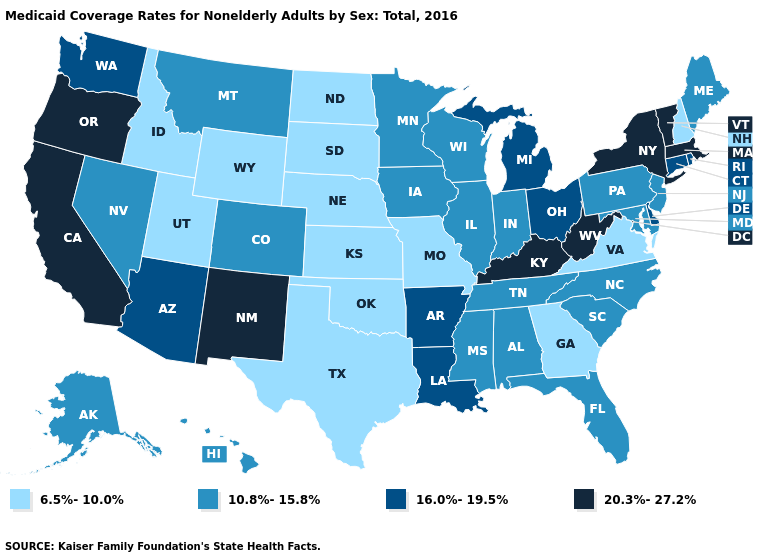Name the states that have a value in the range 20.3%-27.2%?
Be succinct. California, Kentucky, Massachusetts, New Mexico, New York, Oregon, Vermont, West Virginia. Among the states that border Wisconsin , does Iowa have the highest value?
Concise answer only. No. Among the states that border Vermont , does New Hampshire have the lowest value?
Short answer required. Yes. What is the value of Maryland?
Concise answer only. 10.8%-15.8%. Name the states that have a value in the range 6.5%-10.0%?
Keep it brief. Georgia, Idaho, Kansas, Missouri, Nebraska, New Hampshire, North Dakota, Oklahoma, South Dakota, Texas, Utah, Virginia, Wyoming. What is the lowest value in states that border Connecticut?
Answer briefly. 16.0%-19.5%. What is the value of Alaska?
Concise answer only. 10.8%-15.8%. Does the map have missing data?
Give a very brief answer. No. What is the value of Alabama?
Write a very short answer. 10.8%-15.8%. Name the states that have a value in the range 16.0%-19.5%?
Quick response, please. Arizona, Arkansas, Connecticut, Delaware, Louisiana, Michigan, Ohio, Rhode Island, Washington. What is the value of Maine?
Write a very short answer. 10.8%-15.8%. Name the states that have a value in the range 6.5%-10.0%?
Be succinct. Georgia, Idaho, Kansas, Missouri, Nebraska, New Hampshire, North Dakota, Oklahoma, South Dakota, Texas, Utah, Virginia, Wyoming. Does Washington have the lowest value in the USA?
Write a very short answer. No. How many symbols are there in the legend?
Answer briefly. 4. Does Nebraska have a lower value than New Hampshire?
Keep it brief. No. 